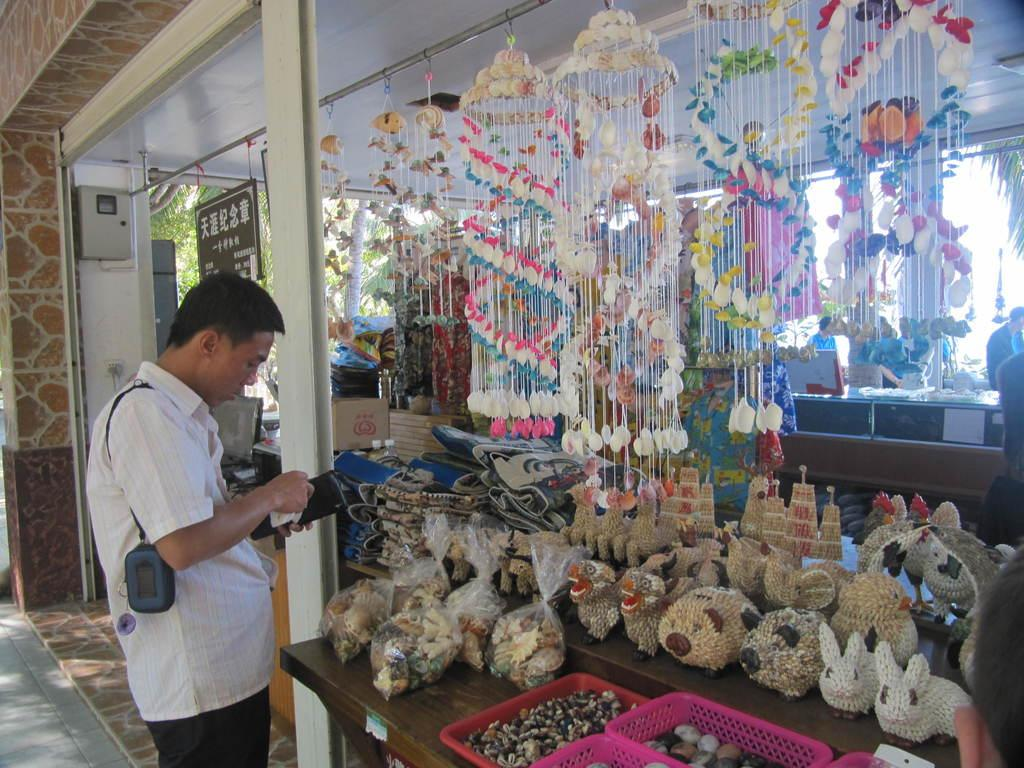What is the person in the image holding? The person is holding a wallet. What type of decorations can be seen in the image? There are decor hangings in the image. What objects are present in the image that can be used for storage? There are baskets in the image. What type of items can be seen in the image that might be used for play? There are toys in the image. What is located at the back of the image? There is a board and trees at the back of the image. How many people are present in the image? People are present in the image. Can you see a swing in the image? There is no swing present in the image. 